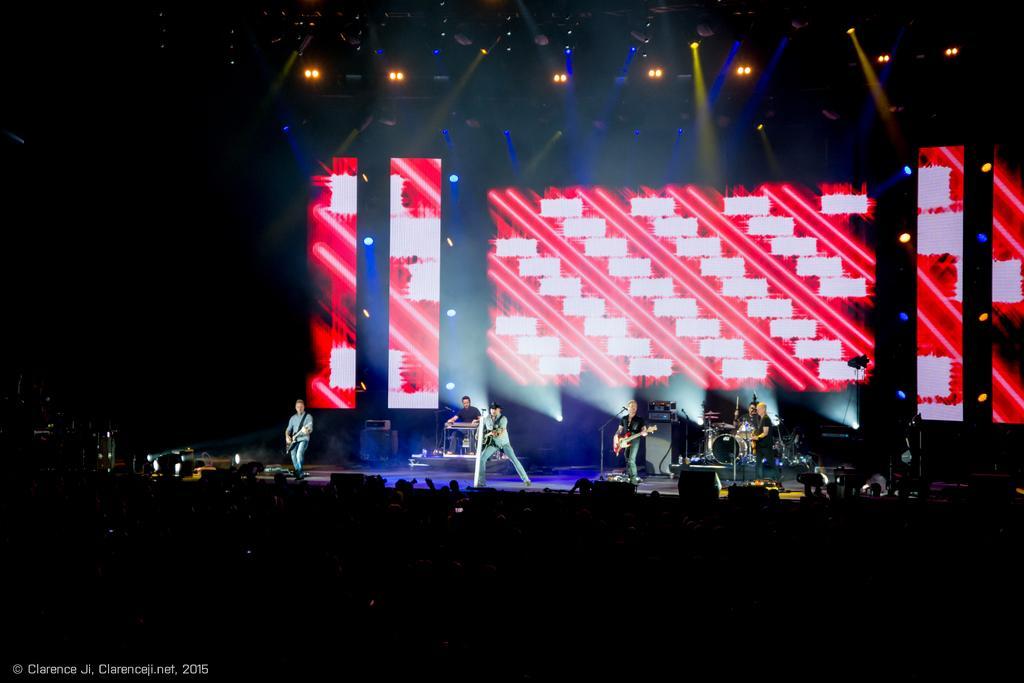Could you give a brief overview of what you see in this image? In this image there is a group of people playing music instruments on a stage, behind them there are led screens which have patterns on it and in front of them there are audience, there are lights on the roof. 